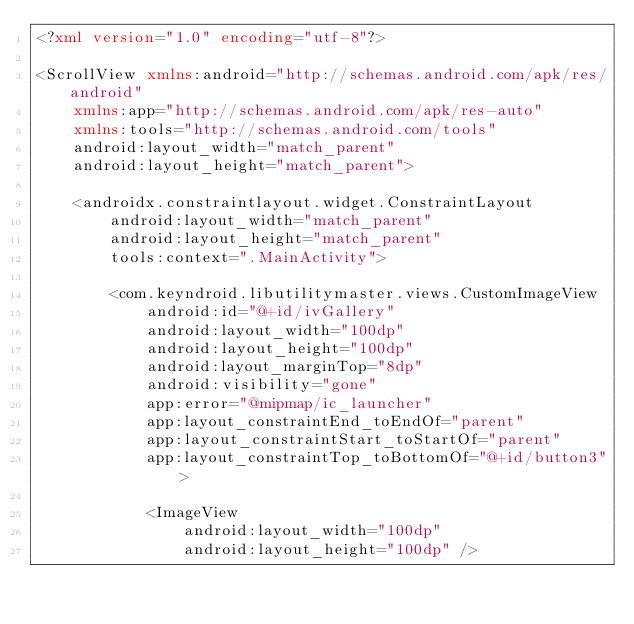Convert code to text. <code><loc_0><loc_0><loc_500><loc_500><_XML_><?xml version="1.0" encoding="utf-8"?>

<ScrollView xmlns:android="http://schemas.android.com/apk/res/android"
    xmlns:app="http://schemas.android.com/apk/res-auto"
    xmlns:tools="http://schemas.android.com/tools"
    android:layout_width="match_parent"
    android:layout_height="match_parent">

    <androidx.constraintlayout.widget.ConstraintLayout
        android:layout_width="match_parent"
        android:layout_height="match_parent"
        tools:context=".MainActivity">

        <com.keyndroid.libutilitymaster.views.CustomImageView
            android:id="@+id/ivGallery"
            android:layout_width="100dp"
            android:layout_height="100dp"
            android:layout_marginTop="8dp"
            android:visibility="gone"
            app:error="@mipmap/ic_launcher"
            app:layout_constraintEnd_toEndOf="parent"
            app:layout_constraintStart_toStartOf="parent"
            app:layout_constraintTop_toBottomOf="@+id/button3">

            <ImageView
                android:layout_width="100dp"
                android:layout_height="100dp" /></code> 